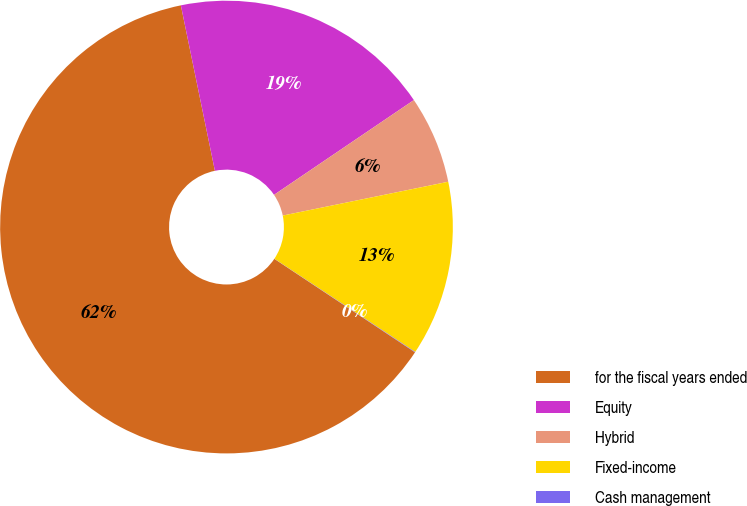Convert chart. <chart><loc_0><loc_0><loc_500><loc_500><pie_chart><fcel>for the fiscal years ended<fcel>Equity<fcel>Hybrid<fcel>Fixed-income<fcel>Cash management<nl><fcel>62.43%<fcel>18.75%<fcel>6.27%<fcel>12.51%<fcel>0.03%<nl></chart> 